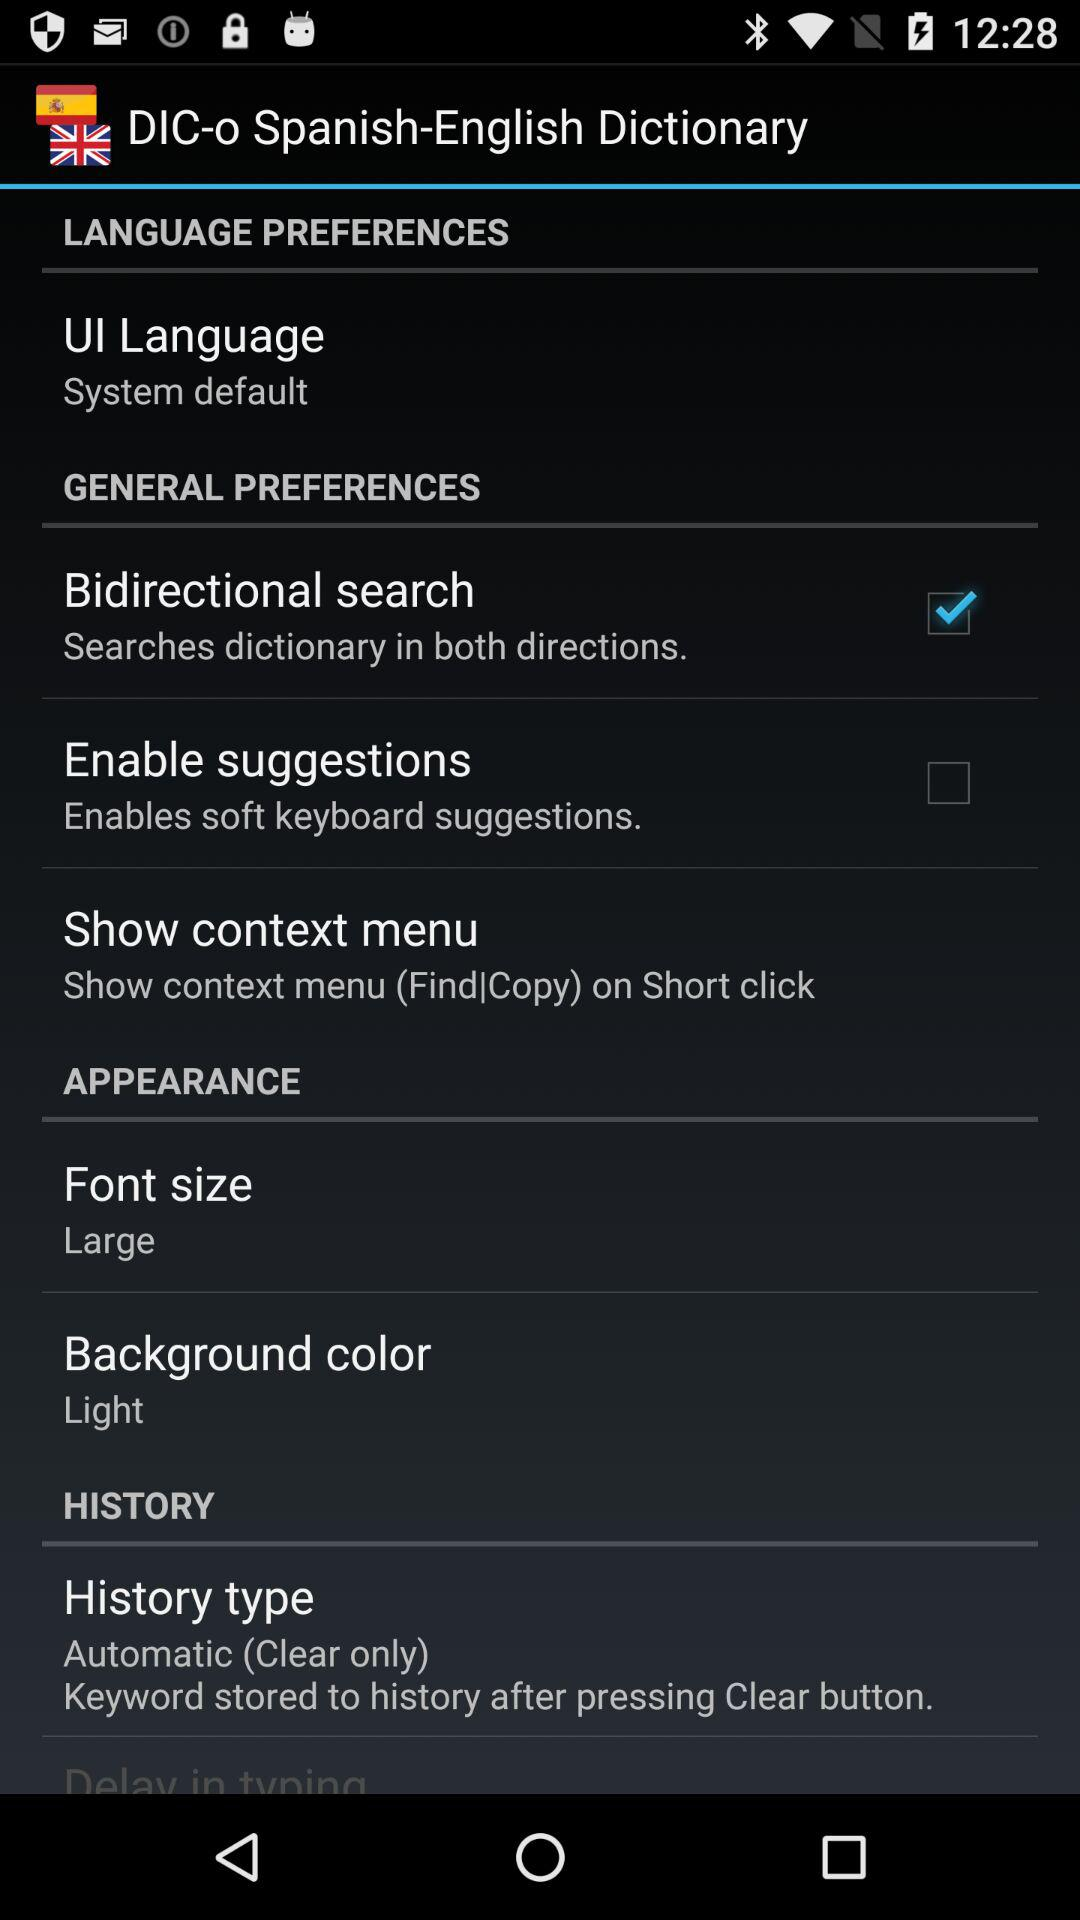How many items have a checkbox in the 'GENERAL PREFERENCES' section?
Answer the question using a single word or phrase. 2 